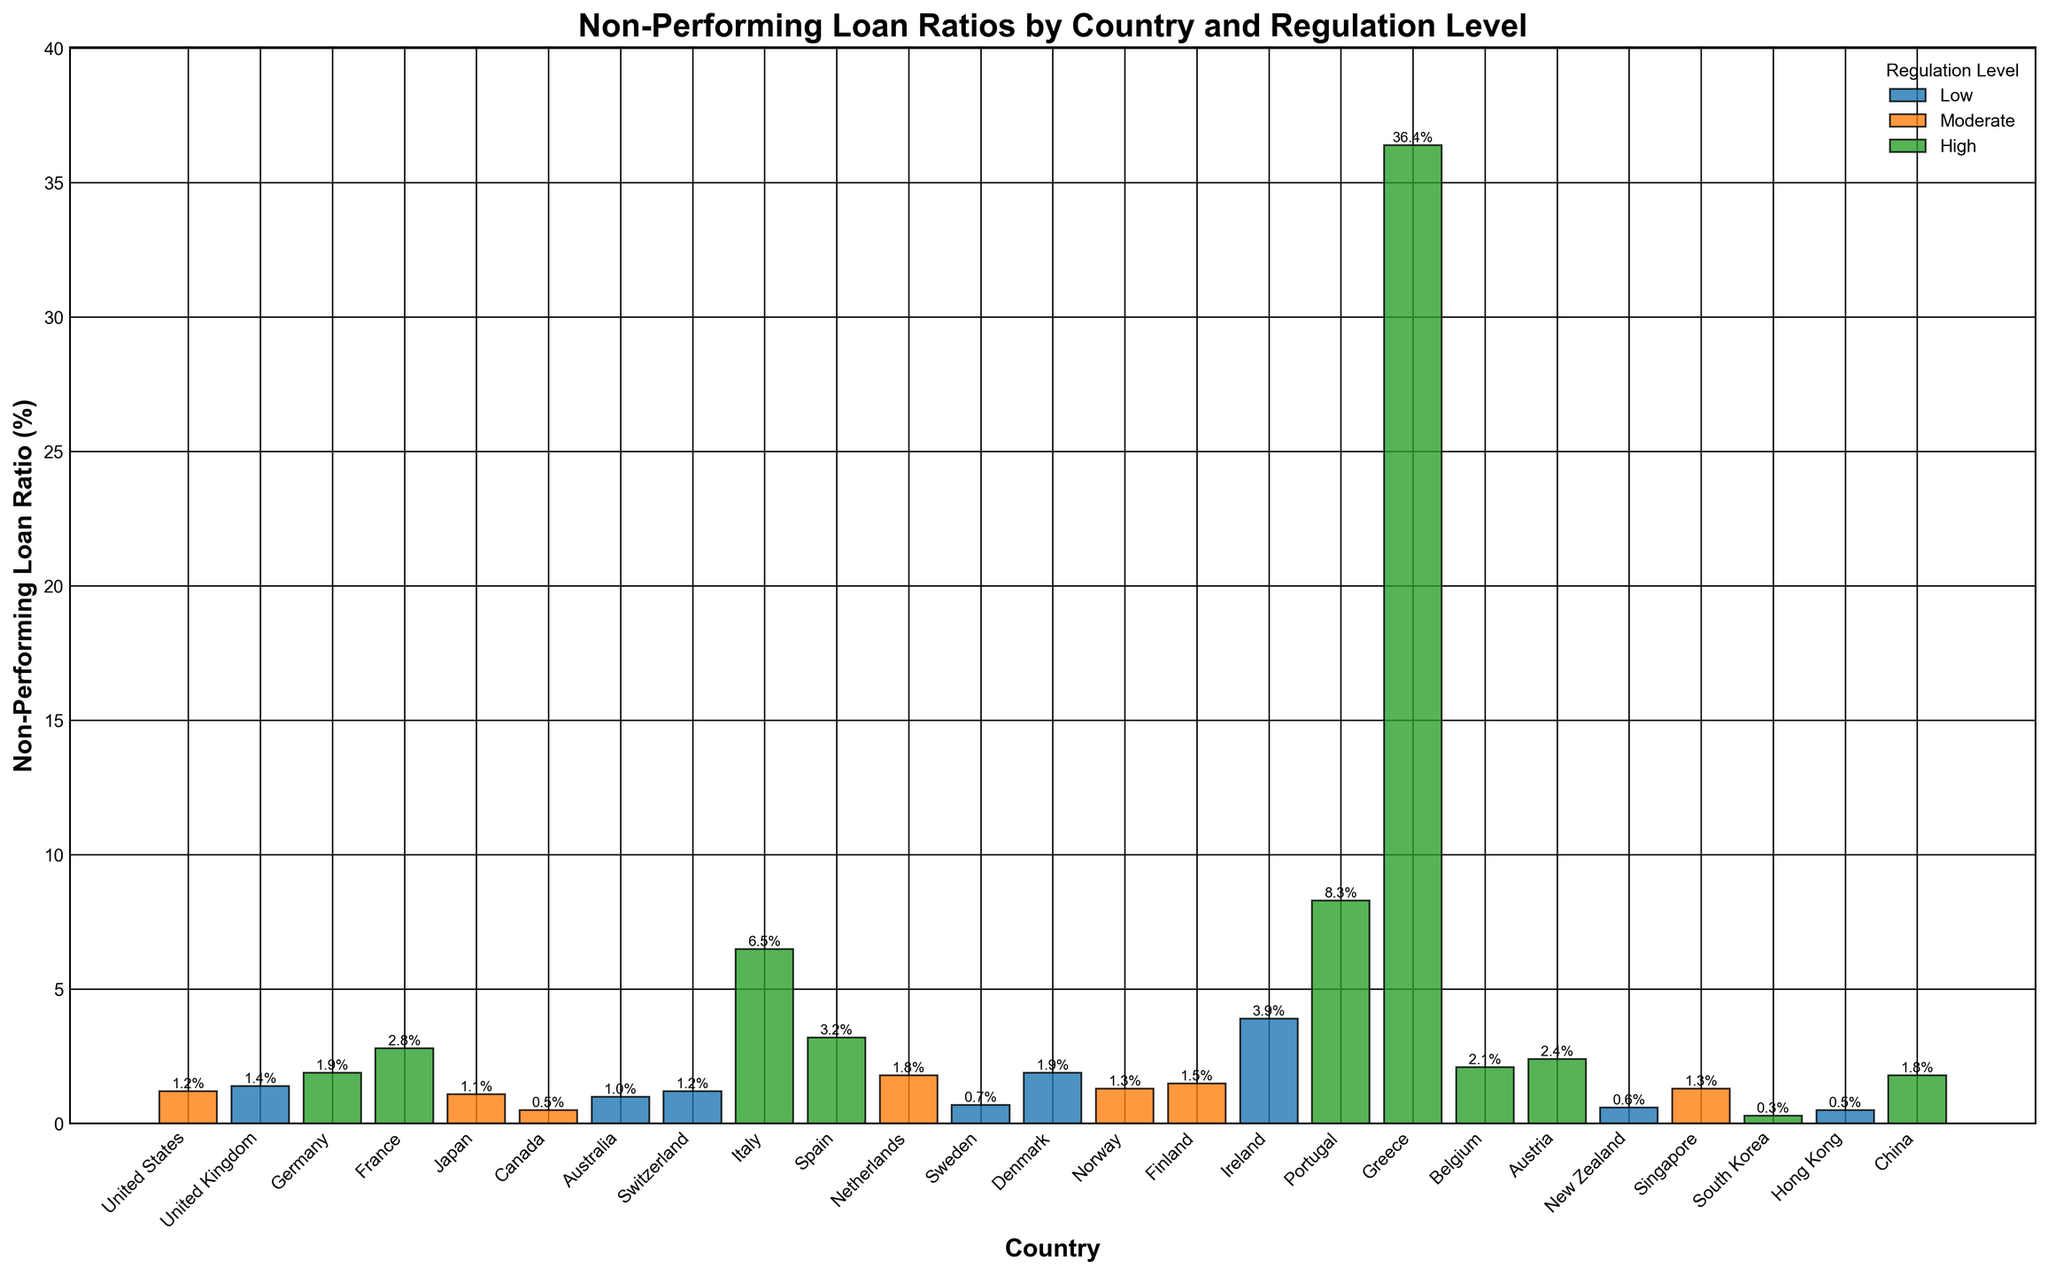What's the country with the highest Non-Performing Loan Ratio? To find the country with the highest Non-Performing Loan Ratio, look for the tallest bar in the chart. The tallest bar represents Greece with a ratio of 36.4%.
Answer: Greece Which country has a lower Non-Performing Loan Ratio, France or Germany? By comparing the heights of the bars, Germany has a lower Non-Performing Loan Ratio (1.9%) compared to France (2.8%).
Answer: Germany What's the average Non-Performing Loan Ratio for 'Moderate' regulation level countries? Identify countries with 'Moderate' regulation level and their ratios: United States (1.2%), Japan (1.1%), Canada (0.5%), Netherlands (1.8%), Norway (1.3%), Finland (1.5%), Singapore (1.3%). Sum these values: 1.2 + 1.1 + 0.5 + 1.8 + 1.3 + 1.5 + 1.3 = 8.7. Divide the sum by the number of countries: 8.7 / 7 ≈ 1.24%.
Answer: 1.24% Which countries have a Non-Performing Loan Ratio greater than 5%? Observe the bars with height greater than 5%. Italy (6.5%), Portugal (8.3%), and Greece (36.4%) fit this criterion.
Answer: Italy, Portugal, Greece What's the total Non-Performing Loan Ratio for countries with 'Low' regulation level? Identify countries with 'Low' regulation: United Kingdom (1.4%), Australia (1.0%), Switzerland (1.2%), Sweden (0.7%), Denmark (1.9%), Ireland (3.9%), New Zealand (0.6%), Hong Kong (0.5%). Sum these ratios: 1.4 + 1.0 + 1.2 + 0.7 + 1.9 + 3.9 + 0.6 + 0.5 = 11.2.
Answer: 11.2% Do any 'Low' regulation level countries have a Non-Performing Loan Ratio below 1%? Check if any bars with 'Low' regulation level are below 1%: Sweden (0.7%), New Zealand (0.6%), Hong Kong (0.5%).
Answer: Yes Which regulation level has the most countries with a Non-Performing Loan Ratio below 2%? Count the countries for each regulation level: 'Low' - United Kingdom (1.4%), Australia (1.0%), Switzerland (1.2%), Sweden (0.7%), Denmark (1.9%), New Zealand (0.6%), Hong Kong (0.5%); 'Moderate' - United States (1.2%), Japan (1.1%), Canada (0.5%), Norway (1.3%), Finland (1.5%), Singapore (1.3%); 'High' - Germany (1.9%), South Korea (0.3%), China (1.8%). 'Low' has 7 countries, 'Moderate' has 6 countries, 'High' has 3 countries.
Answer: Low 